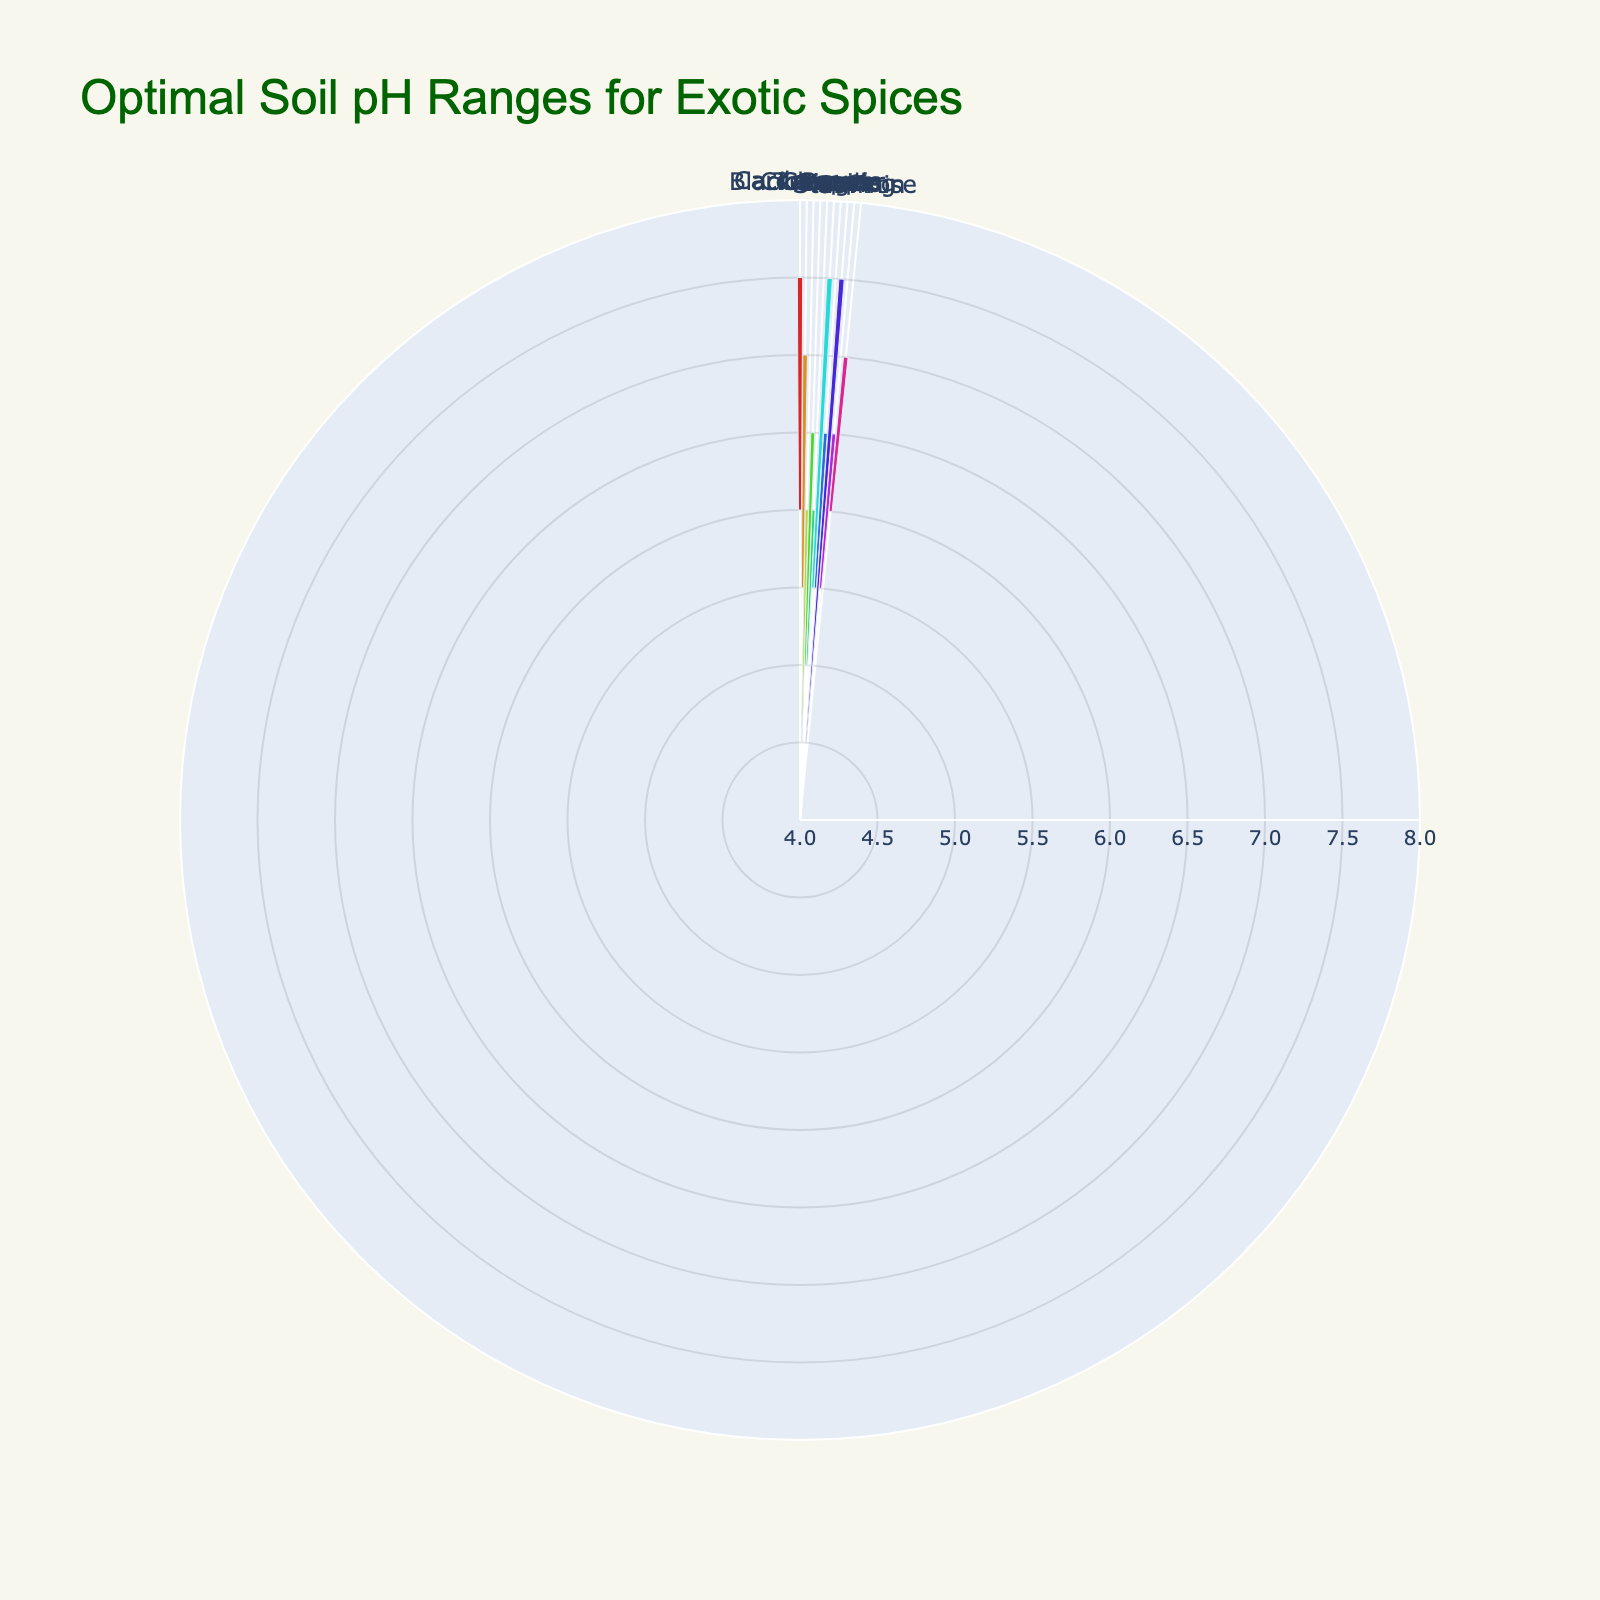What is the title of the rose chart? The title of the rose chart is prominently displayed at the top of the figure.
Answer: Optimal Soil pH Ranges for Exotic Spices How many exotic spices are charted in the figure? The number of segments or categories in the rose chart corresponds to the number of exotic spices represented.
Answer: 10 What is the pH range for Saffron? By looking at the segment labeled 'Saffron', we can read the pH range indicated on the hover text or legend.
Answer: 6.0-7.5 Which spice has the smallest optimal soil pH range? By comparing the lengths of the segments in the rose chart, we can identify the shortest segment representing the narrowest pH range.
Answer: Black Pepper Which spice requires the lowest soil pH for optimal growth? Look for the spice with the shortest segment anchored at the lowest value on the radial axis of the rose chart.
Answer: Cardamom Which spice has the widest optimal soil pH range? By comparing the range amplitudes of all segments, we can identify the spice with the maximum spread between its minimum and maximum pH values.
Answer: Turmeric How does the optimal pH range for Nutmeg compare to that for Cinnamon? By examining and comparing the lengths and positions of the segments for Nutmeg and Cinnamon, we can assess their optimal pH ranges.
Answer: Nutmeg: 5.5-7.5, Cinnamon: 5.5-6.5 What is the mid-point pH value for Vanilla? The mid-point pH value is the average of the minimum and maximum pH values for Vanilla.
Answer: (5.5 + 7.0) / 2 = 6.25 Name all the spices that have an upper pH limit of 7.0 or higher. By observing the ending points of the segments, we can identify the spices with upper pH limits of 7.0 or more.
Answer: Saffron, Vanilla, Nutmeg, Turmeric For Ginger, what are the minimum and maximum optimal pH values, and how do they compare with those of Clove? By checking the segments for Ginger and Clove, we can read off and compare their respective pH ranges.
Answer: Ginger: 5.5-6.5, Clove: 5.0-6.5 